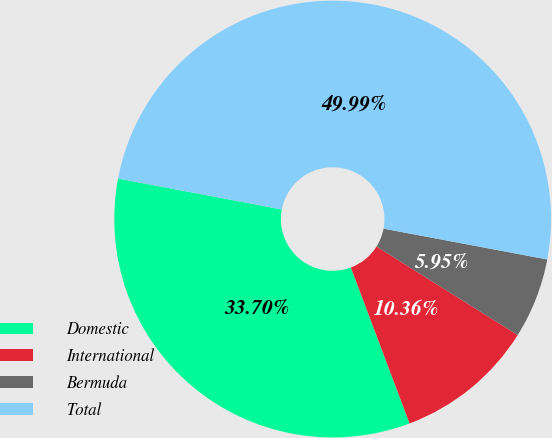Convert chart. <chart><loc_0><loc_0><loc_500><loc_500><pie_chart><fcel>Domestic<fcel>International<fcel>Bermuda<fcel>Total<nl><fcel>33.7%<fcel>10.36%<fcel>5.95%<fcel>49.99%<nl></chart> 